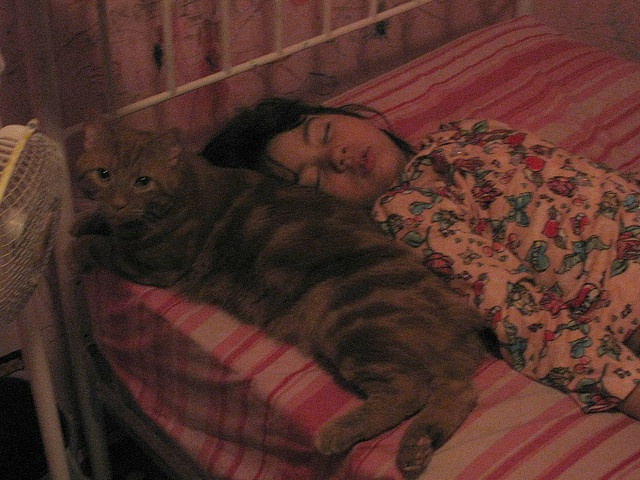Describe the objects in this image and their specific colors. I can see bed in maroon, black, and brown tones, cat in maroon, black, and brown tones, and people in maroon, black, and brown tones in this image. 